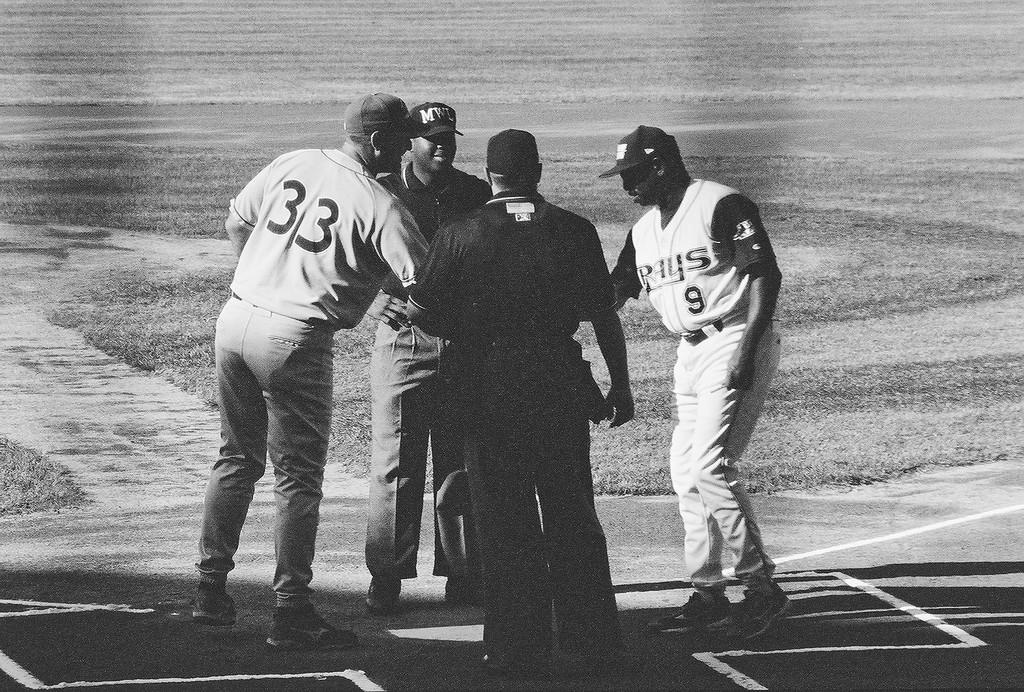<image>
Provide a brief description of the given image. Some sports people, one of whom is wearing a 33 shirt. 